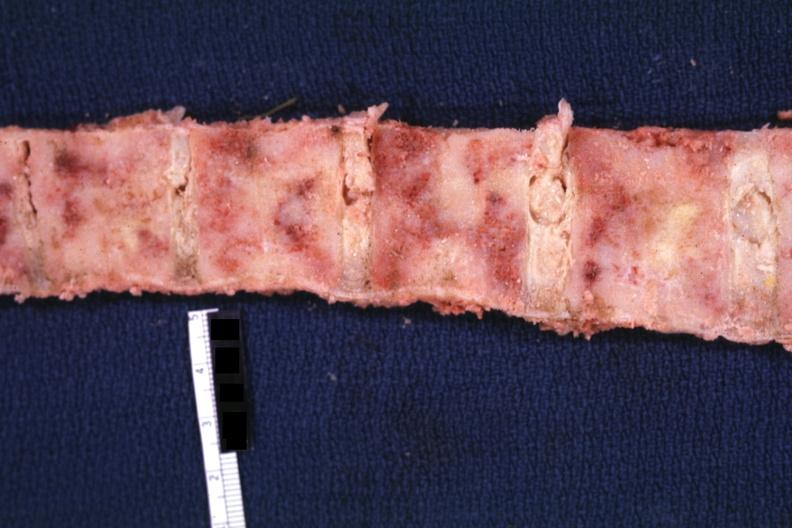what is present?
Answer the question using a single word or phrase. Joints 